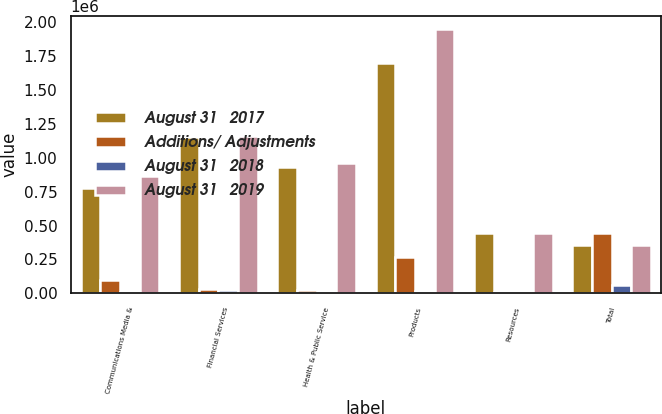<chart> <loc_0><loc_0><loc_500><loc_500><stacked_bar_chart><ecel><fcel>Communications Media &<fcel>Financial Services<fcel>Health & Public Service<fcel>Products<fcel>Resources<fcel>Total<nl><fcel>August 31   2017<fcel>775802<fcel>1.15102e+06<fcel>934374<fcel>1.69814e+06<fcel>443012<fcel>356497<nl><fcel>Additions/ Adjustments<fcel>98223<fcel>32390<fcel>27816<fcel>270701<fcel>13163<fcel>442293<nl><fcel>August 31   2018<fcel>8516<fcel>21348<fcel>3142<fcel>20440<fcel>8187<fcel>61633<nl><fcel>August 31   2019<fcel>865509<fcel>1.16207e+06<fcel>959048<fcel>1.9484e+06<fcel>447988<fcel>356497<nl></chart> 